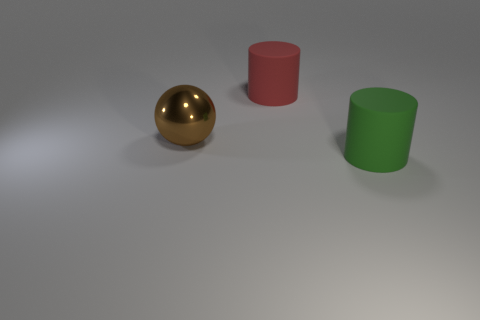Subtract all balls. How many objects are left? 2 Add 2 tiny red blocks. How many objects exist? 5 Subtract all red cylinders. How many cylinders are left? 1 Subtract 0 green balls. How many objects are left? 3 Subtract all green cylinders. Subtract all cyan cubes. How many cylinders are left? 1 Subtract all brown balls. How many red cylinders are left? 1 Subtract all big gray blocks. Subtract all green rubber things. How many objects are left? 2 Add 1 metal balls. How many metal balls are left? 2 Add 3 big red matte cylinders. How many big red matte cylinders exist? 4 